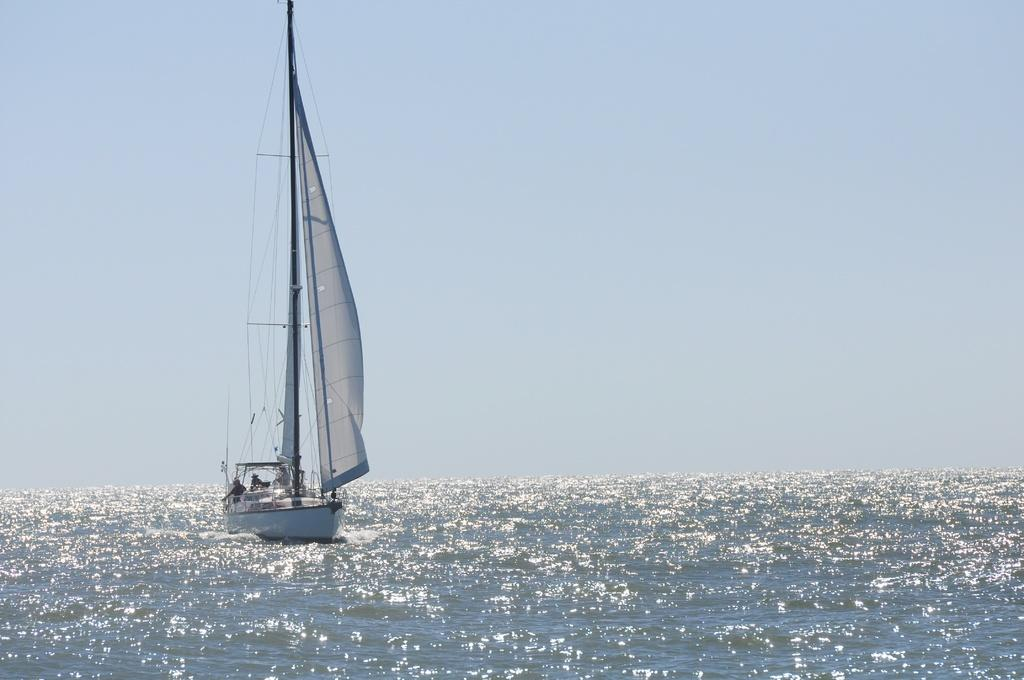What is the main subject of the image? The main subject of the image is a boat. What is the boat doing in the image? The boat is sailing on the water surface. What feature can be seen on the boat? The boat has a large mast. How many eyes can be seen on the boat in the image? There are no eyes visible on the boat in the image, as boats do not have eyes. 